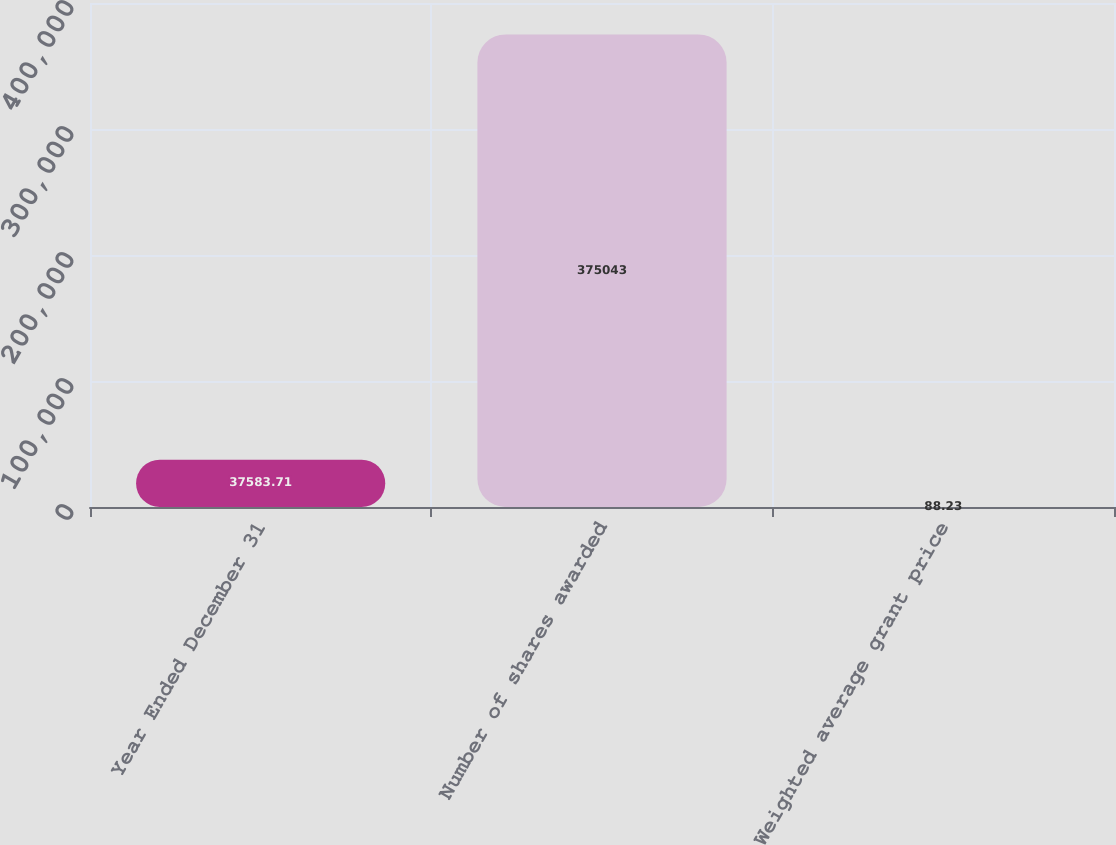Convert chart to OTSL. <chart><loc_0><loc_0><loc_500><loc_500><bar_chart><fcel>Year Ended December 31<fcel>Number of shares awarded<fcel>Weighted average grant price<nl><fcel>37583.7<fcel>375043<fcel>88.23<nl></chart> 